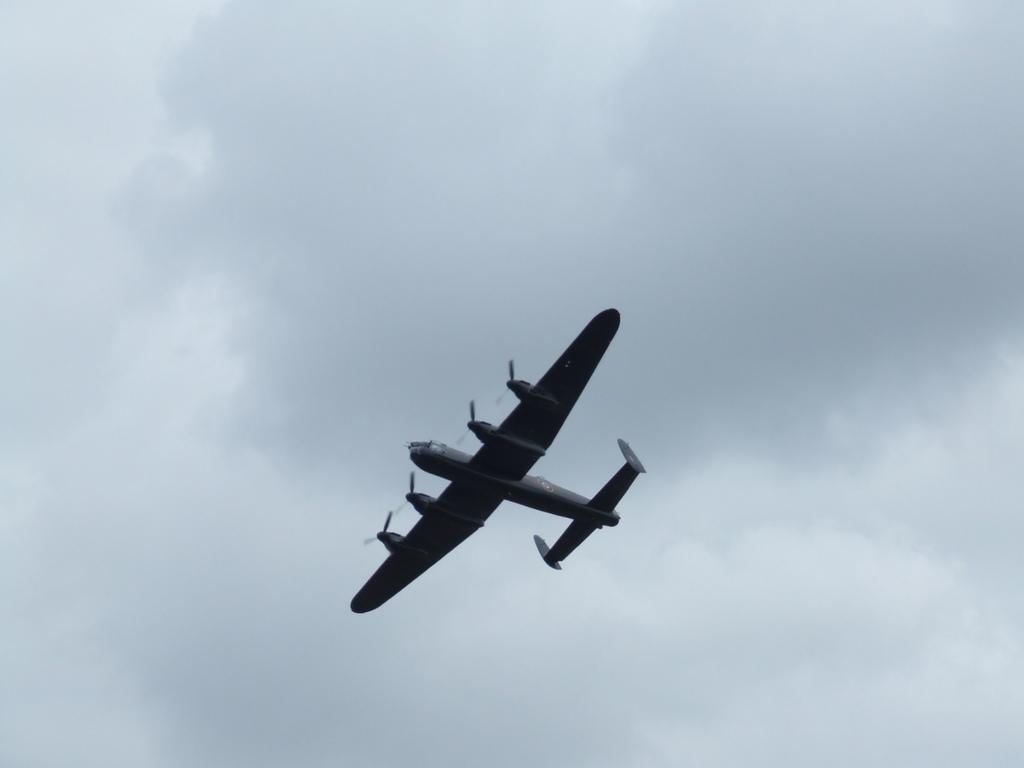What is the main subject of the image? The main subject of the image is an aircraft. Where is the aircraft located in the image? The aircraft is in the air in the image. What can be seen in the background of the image? The sky is visible in the image. Can we determine the time of day from the image? The image might have been taken during the day, but we cannot determine the exact time. What type of arm is visible on the aircraft in the image? There are no arms visible on the aircraft in the image, as it is a machine and not a living being. What does the aircraft feel about its performance in the image? The aircraft is an inanimate object and does not have feelings or emotions, so it cannot feel shame or any other emotion. 